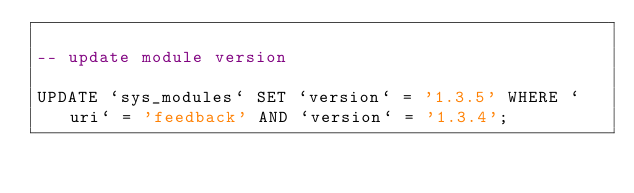<code> <loc_0><loc_0><loc_500><loc_500><_SQL_>
-- update module version

UPDATE `sys_modules` SET `version` = '1.3.5' WHERE `uri` = 'feedback' AND `version` = '1.3.4';

</code> 